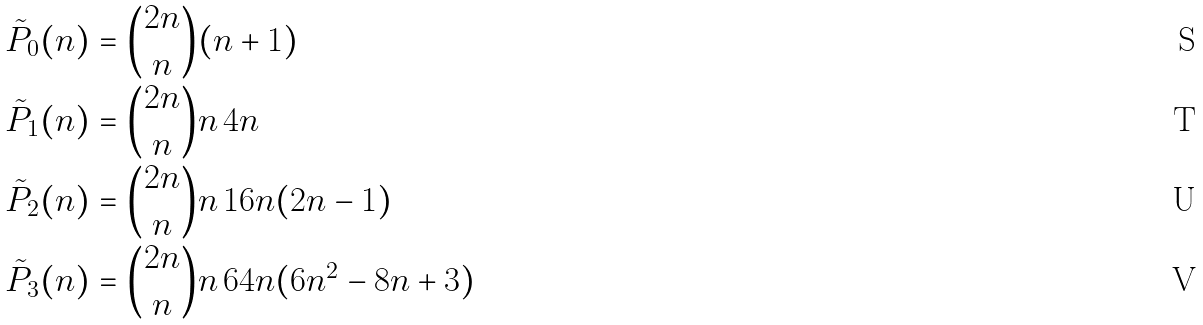<formula> <loc_0><loc_0><loc_500><loc_500>\tilde { P } _ { 0 } ( n ) & = \binom { 2 n } { n } ( n + 1 ) \\ \tilde { P } _ { 1 } ( n ) & = \binom { 2 n } { n } n \, 4 n \\ \tilde { P } _ { 2 } ( n ) & = \binom { 2 n } { n } n \, 1 6 n ( 2 n - 1 ) \\ \tilde { P } _ { 3 } ( n ) & = \binom { 2 n } { n } n \, 6 4 n ( 6 n ^ { 2 } - 8 n + 3 )</formula> 